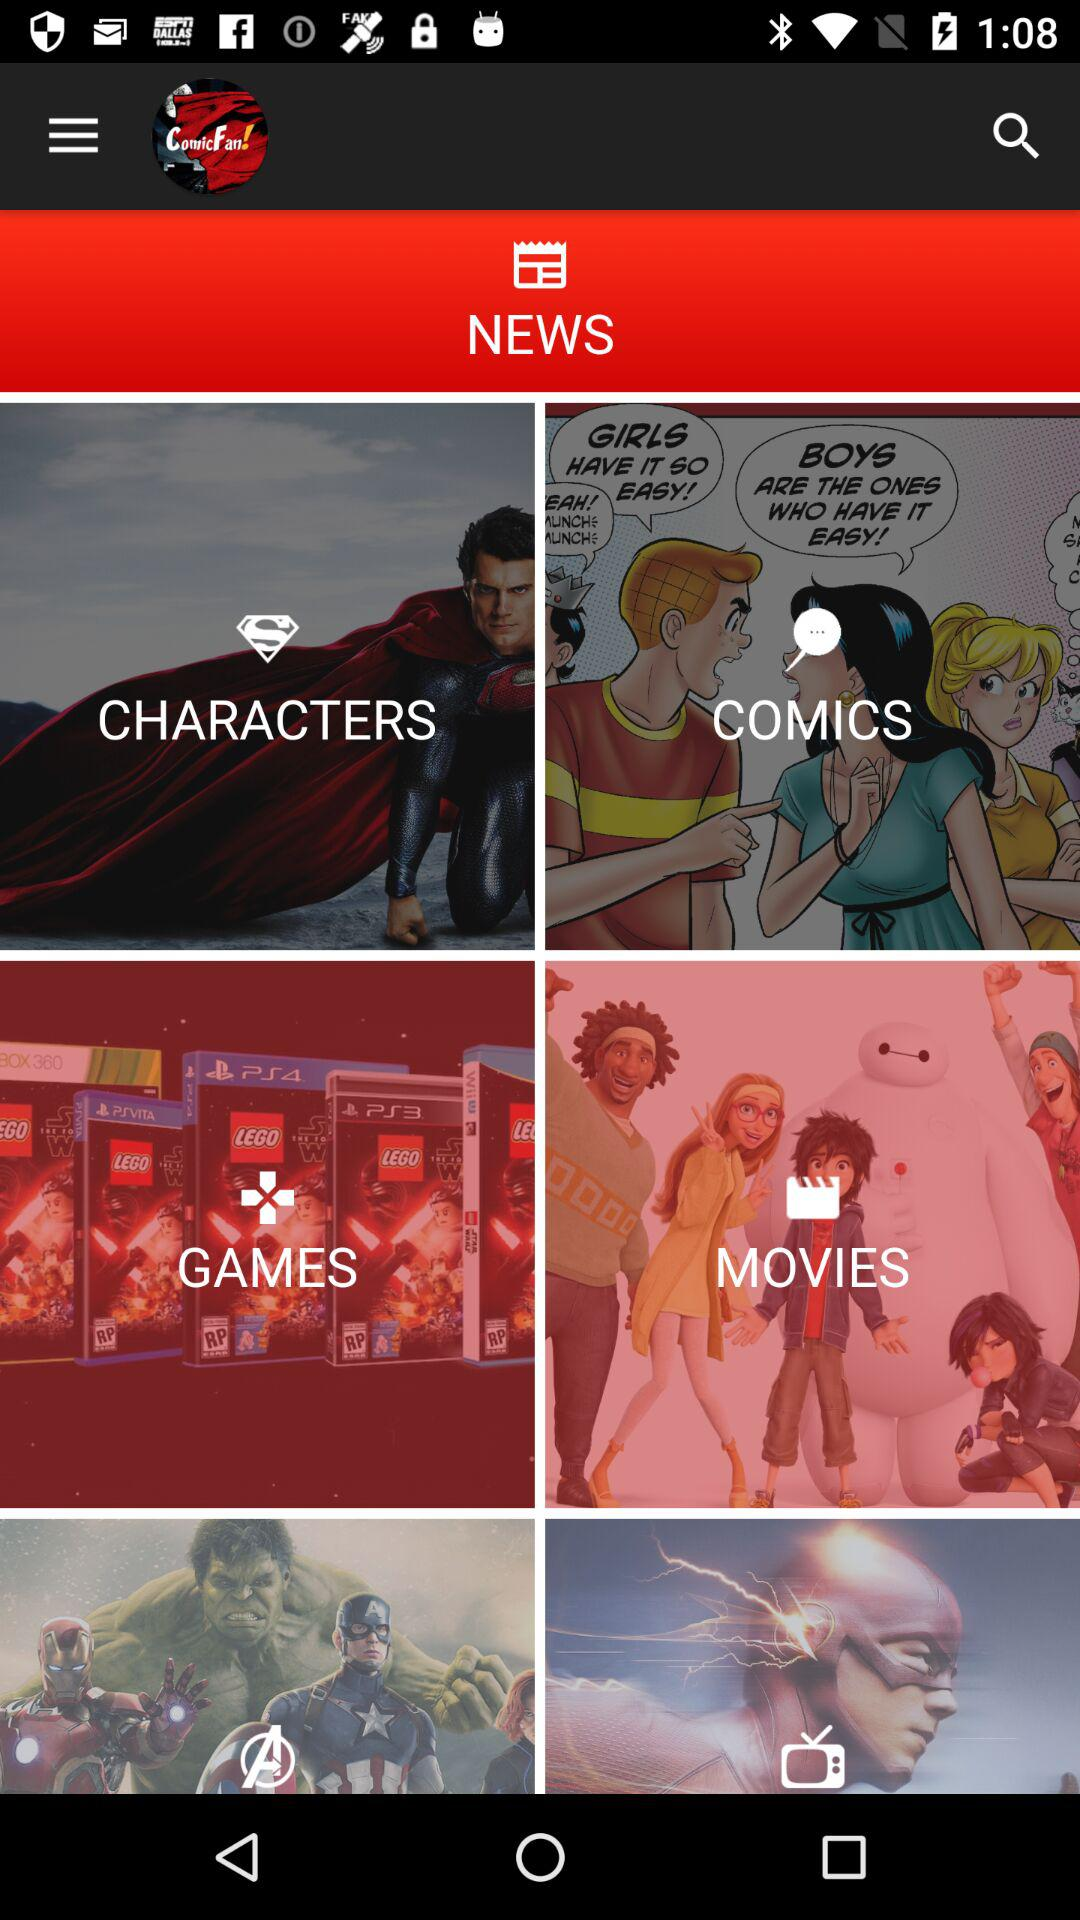What section of the application is shown? The section of the application shown is "NEWS". 